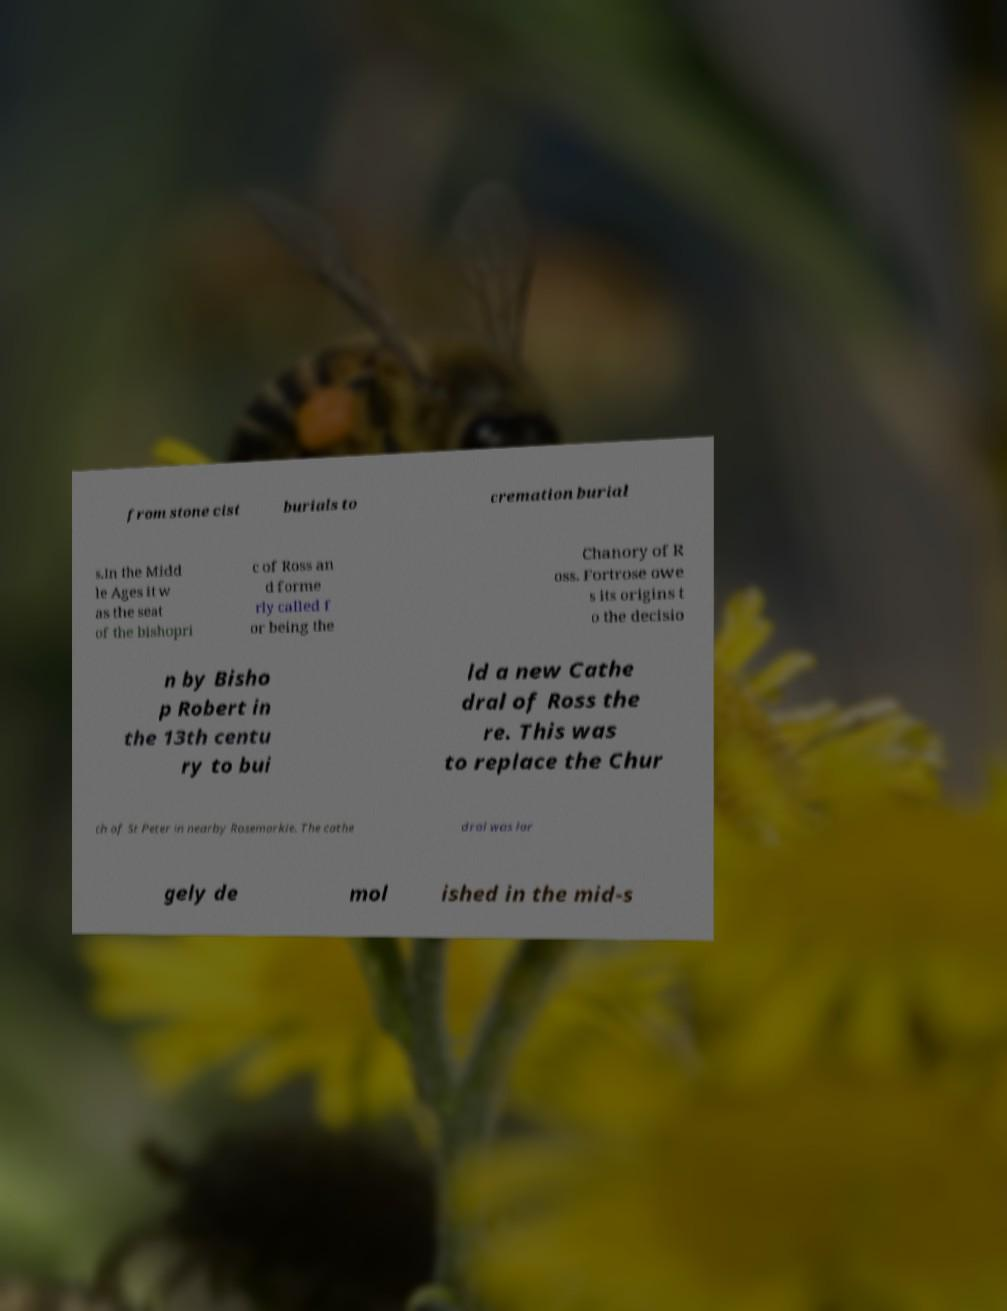Please identify and transcribe the text found in this image. from stone cist burials to cremation burial s.In the Midd le Ages it w as the seat of the bishopri c of Ross an d forme rly called f or being the Chanory of R oss. Fortrose owe s its origins t o the decisio n by Bisho p Robert in the 13th centu ry to bui ld a new Cathe dral of Ross the re. This was to replace the Chur ch of St Peter in nearby Rosemarkie. The cathe dral was lar gely de mol ished in the mid-s 